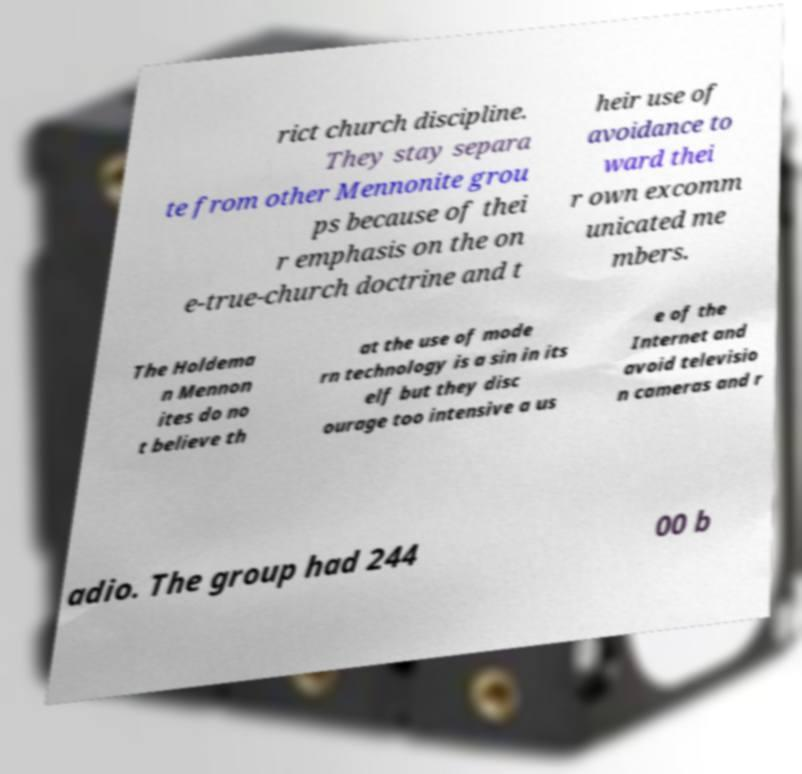Can you read and provide the text displayed in the image?This photo seems to have some interesting text. Can you extract and type it out for me? rict church discipline. They stay separa te from other Mennonite grou ps because of thei r emphasis on the on e-true-church doctrine and t heir use of avoidance to ward thei r own excomm unicated me mbers. The Holdema n Mennon ites do no t believe th at the use of mode rn technology is a sin in its elf but they disc ourage too intensive a us e of the Internet and avoid televisio n cameras and r adio. The group had 244 00 b 